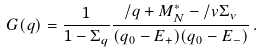<formula> <loc_0><loc_0><loc_500><loc_500>G ( q ) = \frac { 1 } { 1 - \Sigma _ { q } } \frac { \slash { q } + M _ { N } ^ { * } - \slash { v } \Sigma _ { v } } { ( q _ { 0 } - E _ { + } ) ( q _ { 0 } - E _ { - } ) } \, .</formula> 